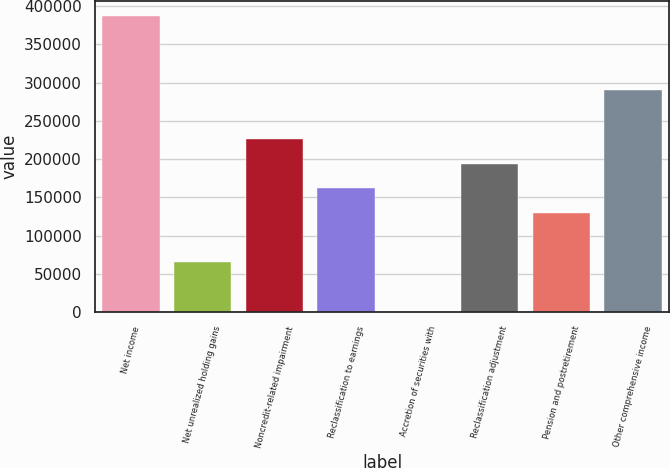<chart> <loc_0><loc_0><loc_500><loc_500><bar_chart><fcel>Net income<fcel>Net unrealized holding gains<fcel>Noncredit-related impairment<fcel>Reclassification to earnings<fcel>Accretion of securities with<fcel>Reclassification adjustment<fcel>Pension and postretirement<fcel>Other comprehensive income<nl><fcel>387146<fcel>64866<fcel>226006<fcel>161550<fcel>410<fcel>193778<fcel>129322<fcel>290462<nl></chart> 